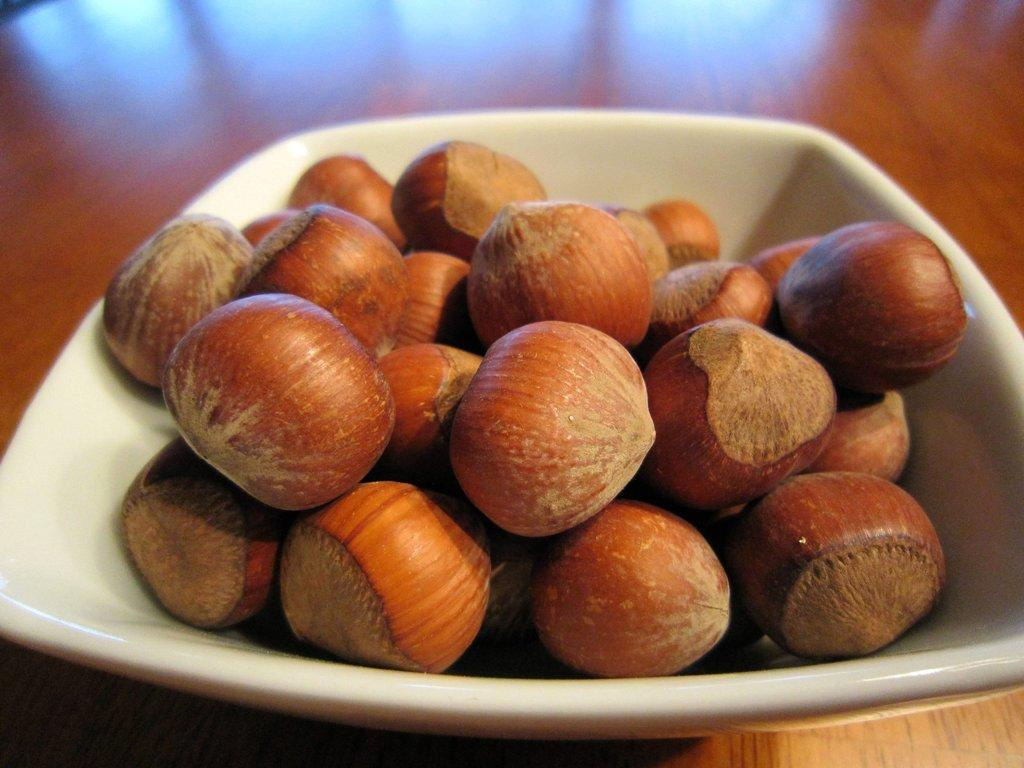What is in the bowl that is visible in the image? There are nuts in the bowl in the image. Can you describe the wooden object in the background of the image? There is a wooden object that looks like a table in the background of the image. What type of sea creature can be seen swimming in the bowl with the nuts? There is no sea creature present in the image; the bowl contains only nuts. 